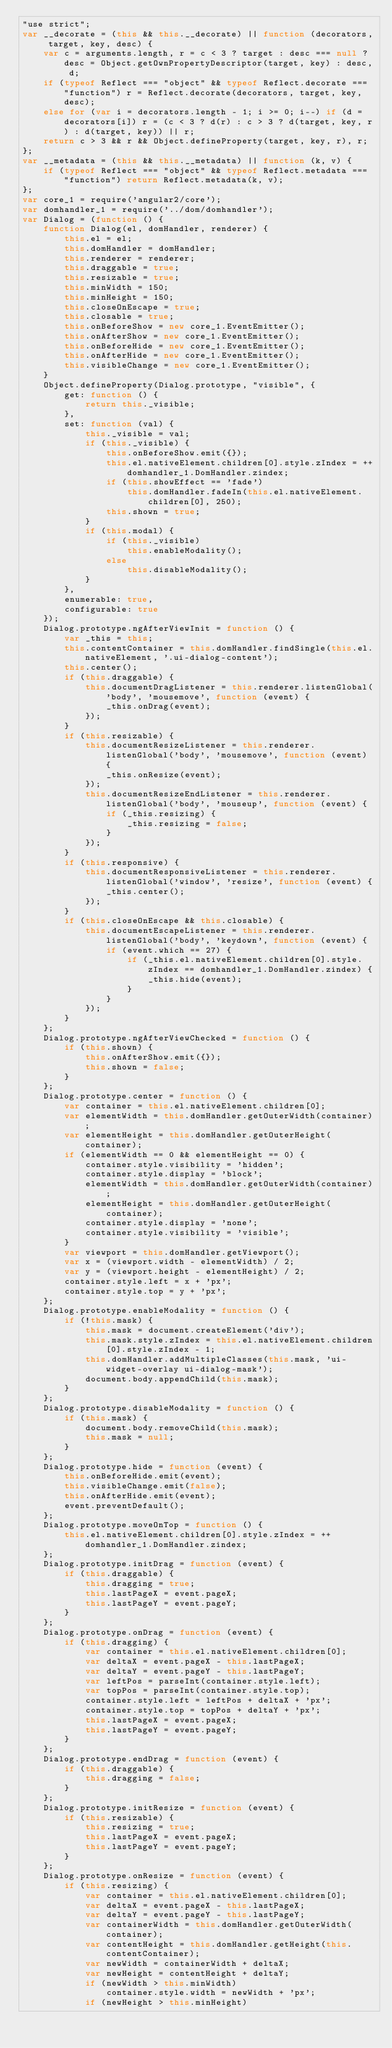Convert code to text. <code><loc_0><loc_0><loc_500><loc_500><_JavaScript_>"use strict";
var __decorate = (this && this.__decorate) || function (decorators, target, key, desc) {
    var c = arguments.length, r = c < 3 ? target : desc === null ? desc = Object.getOwnPropertyDescriptor(target, key) : desc, d;
    if (typeof Reflect === "object" && typeof Reflect.decorate === "function") r = Reflect.decorate(decorators, target, key, desc);
    else for (var i = decorators.length - 1; i >= 0; i--) if (d = decorators[i]) r = (c < 3 ? d(r) : c > 3 ? d(target, key, r) : d(target, key)) || r;
    return c > 3 && r && Object.defineProperty(target, key, r), r;
};
var __metadata = (this && this.__metadata) || function (k, v) {
    if (typeof Reflect === "object" && typeof Reflect.metadata === "function") return Reflect.metadata(k, v);
};
var core_1 = require('angular2/core');
var domhandler_1 = require('../dom/domhandler');
var Dialog = (function () {
    function Dialog(el, domHandler, renderer) {
        this.el = el;
        this.domHandler = domHandler;
        this.renderer = renderer;
        this.draggable = true;
        this.resizable = true;
        this.minWidth = 150;
        this.minHeight = 150;
        this.closeOnEscape = true;
        this.closable = true;
        this.onBeforeShow = new core_1.EventEmitter();
        this.onAfterShow = new core_1.EventEmitter();
        this.onBeforeHide = new core_1.EventEmitter();
        this.onAfterHide = new core_1.EventEmitter();
        this.visibleChange = new core_1.EventEmitter();
    }
    Object.defineProperty(Dialog.prototype, "visible", {
        get: function () {
            return this._visible;
        },
        set: function (val) {
            this._visible = val;
            if (this._visible) {
                this.onBeforeShow.emit({});
                this.el.nativeElement.children[0].style.zIndex = ++domhandler_1.DomHandler.zindex;
                if (this.showEffect == 'fade')
                    this.domHandler.fadeIn(this.el.nativeElement.children[0], 250);
                this.shown = true;
            }
            if (this.modal) {
                if (this._visible)
                    this.enableModality();
                else
                    this.disableModality();
            }
        },
        enumerable: true,
        configurable: true
    });
    Dialog.prototype.ngAfterViewInit = function () {
        var _this = this;
        this.contentContainer = this.domHandler.findSingle(this.el.nativeElement, '.ui-dialog-content');
        this.center();
        if (this.draggable) {
            this.documentDragListener = this.renderer.listenGlobal('body', 'mousemove', function (event) {
                _this.onDrag(event);
            });
        }
        if (this.resizable) {
            this.documentResizeListener = this.renderer.listenGlobal('body', 'mousemove', function (event) {
                _this.onResize(event);
            });
            this.documentResizeEndListener = this.renderer.listenGlobal('body', 'mouseup', function (event) {
                if (_this.resizing) {
                    _this.resizing = false;
                }
            });
        }
        if (this.responsive) {
            this.documentResponsiveListener = this.renderer.listenGlobal('window', 'resize', function (event) {
                _this.center();
            });
        }
        if (this.closeOnEscape && this.closable) {
            this.documentEscapeListener = this.renderer.listenGlobal('body', 'keydown', function (event) {
                if (event.which == 27) {
                    if (_this.el.nativeElement.children[0].style.zIndex == domhandler_1.DomHandler.zindex) {
                        _this.hide(event);
                    }
                }
            });
        }
    };
    Dialog.prototype.ngAfterViewChecked = function () {
        if (this.shown) {
            this.onAfterShow.emit({});
            this.shown = false;
        }
    };
    Dialog.prototype.center = function () {
        var container = this.el.nativeElement.children[0];
        var elementWidth = this.domHandler.getOuterWidth(container);
        var elementHeight = this.domHandler.getOuterHeight(container);
        if (elementWidth == 0 && elementHeight == 0) {
            container.style.visibility = 'hidden';
            container.style.display = 'block';
            elementWidth = this.domHandler.getOuterWidth(container);
            elementHeight = this.domHandler.getOuterHeight(container);
            container.style.display = 'none';
            container.style.visibility = 'visible';
        }
        var viewport = this.domHandler.getViewport();
        var x = (viewport.width - elementWidth) / 2;
        var y = (viewport.height - elementHeight) / 2;
        container.style.left = x + 'px';
        container.style.top = y + 'px';
    };
    Dialog.prototype.enableModality = function () {
        if (!this.mask) {
            this.mask = document.createElement('div');
            this.mask.style.zIndex = this.el.nativeElement.children[0].style.zIndex - 1;
            this.domHandler.addMultipleClasses(this.mask, 'ui-widget-overlay ui-dialog-mask');
            document.body.appendChild(this.mask);
        }
    };
    Dialog.prototype.disableModality = function () {
        if (this.mask) {
            document.body.removeChild(this.mask);
            this.mask = null;
        }
    };
    Dialog.prototype.hide = function (event) {
        this.onBeforeHide.emit(event);
        this.visibleChange.emit(false);
        this.onAfterHide.emit(event);
        event.preventDefault();
    };
    Dialog.prototype.moveOnTop = function () {
        this.el.nativeElement.children[0].style.zIndex = ++domhandler_1.DomHandler.zindex;
    };
    Dialog.prototype.initDrag = function (event) {
        if (this.draggable) {
            this.dragging = true;
            this.lastPageX = event.pageX;
            this.lastPageY = event.pageY;
        }
    };
    Dialog.prototype.onDrag = function (event) {
        if (this.dragging) {
            var container = this.el.nativeElement.children[0];
            var deltaX = event.pageX - this.lastPageX;
            var deltaY = event.pageY - this.lastPageY;
            var leftPos = parseInt(container.style.left);
            var topPos = parseInt(container.style.top);
            container.style.left = leftPos + deltaX + 'px';
            container.style.top = topPos + deltaY + 'px';
            this.lastPageX = event.pageX;
            this.lastPageY = event.pageY;
        }
    };
    Dialog.prototype.endDrag = function (event) {
        if (this.draggable) {
            this.dragging = false;
        }
    };
    Dialog.prototype.initResize = function (event) {
        if (this.resizable) {
            this.resizing = true;
            this.lastPageX = event.pageX;
            this.lastPageY = event.pageY;
        }
    };
    Dialog.prototype.onResize = function (event) {
        if (this.resizing) {
            var container = this.el.nativeElement.children[0];
            var deltaX = event.pageX - this.lastPageX;
            var deltaY = event.pageY - this.lastPageY;
            var containerWidth = this.domHandler.getOuterWidth(container);
            var contentHeight = this.domHandler.getHeight(this.contentContainer);
            var newWidth = containerWidth + deltaX;
            var newHeight = contentHeight + deltaY;
            if (newWidth > this.minWidth)
                container.style.width = newWidth + 'px';
            if (newHeight > this.minHeight)</code> 